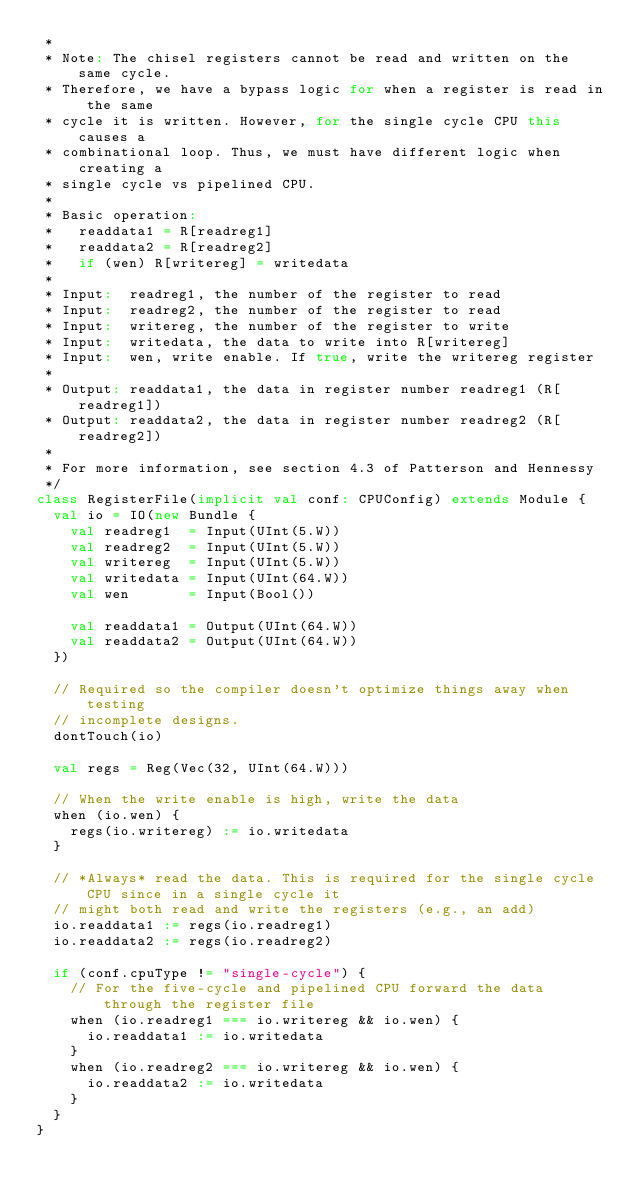<code> <loc_0><loc_0><loc_500><loc_500><_Scala_> *
 * Note: The chisel registers cannot be read and written on the same cycle.
 * Therefore, we have a bypass logic for when a register is read in the same
 * cycle it is written. However, for the single cycle CPU this causes a
 * combinational loop. Thus, we must have different logic when creating a
 * single cycle vs pipelined CPU.
 *
 * Basic operation:
 *   readdata1 = R[readreg1]
 *   readdata2 = R[readreg2]
 *   if (wen) R[writereg] = writedata
 *
 * Input:  readreg1, the number of the register to read
 * Input:  readreg2, the number of the register to read
 * Input:  writereg, the number of the register to write
 * Input:  writedata, the data to write into R[writereg]
 * Input:  wen, write enable. If true, write the writereg register
 *
 * Output: readdata1, the data in register number readreg1 (R[readreg1])
 * Output: readdata2, the data in register number readreg2 (R[readreg2])
 *
 * For more information, see section 4.3 of Patterson and Hennessy
 */
class RegisterFile(implicit val conf: CPUConfig) extends Module {
  val io = IO(new Bundle {
    val readreg1  = Input(UInt(5.W))
    val readreg2  = Input(UInt(5.W))
    val writereg  = Input(UInt(5.W))
    val writedata = Input(UInt(64.W))
    val wen       = Input(Bool())

    val readdata1 = Output(UInt(64.W))
    val readdata2 = Output(UInt(64.W))
  })

  // Required so the compiler doesn't optimize things away when testing
  // incomplete designs.
  dontTouch(io)

  val regs = Reg(Vec(32, UInt(64.W)))

  // When the write enable is high, write the data
  when (io.wen) {
    regs(io.writereg) := io.writedata
  }

  // *Always* read the data. This is required for the single cycle CPU since in a single cycle it
  // might both read and write the registers (e.g., an add)
  io.readdata1 := regs(io.readreg1)
  io.readdata2 := regs(io.readreg2)

  if (conf.cpuType != "single-cycle") {
    // For the five-cycle and pipelined CPU forward the data through the register file
    when (io.readreg1 === io.writereg && io.wen) {
      io.readdata1 := io.writedata
    }
    when (io.readreg2 === io.writereg && io.wen) {
      io.readdata2 := io.writedata
    }
  }
}
</code> 